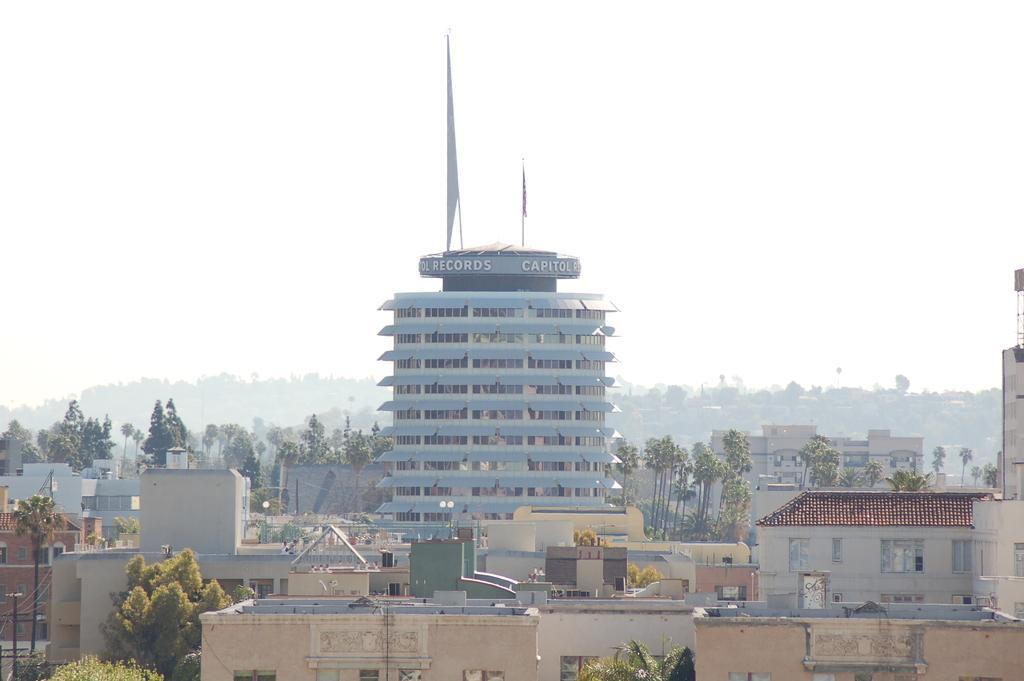Could you give a brief overview of what you see in this image? In this picture I can see the buildings, sheds and house. Beside that I can see the trees and plants. In the center I can see the flags which are placed on the roof of the building. At the top I can see the sky. 